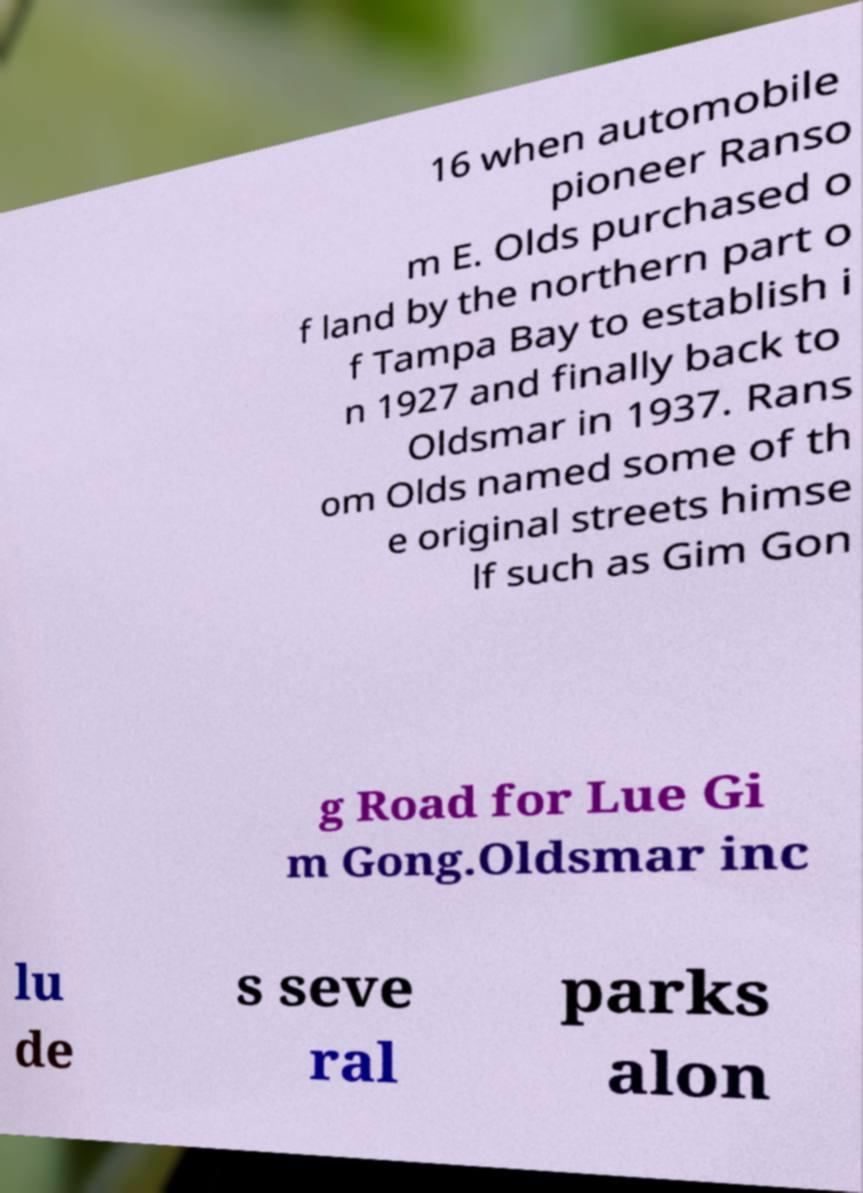Please identify and transcribe the text found in this image. 16 when automobile pioneer Ranso m E. Olds purchased o f land by the northern part o f Tampa Bay to establish i n 1927 and finally back to Oldsmar in 1937. Rans om Olds named some of th e original streets himse lf such as Gim Gon g Road for Lue Gi m Gong.Oldsmar inc lu de s seve ral parks alon 